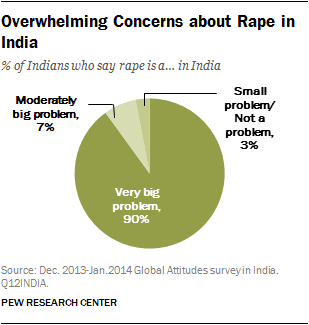Indicate a few pertinent items in this graphic. The ratio of the largest segment to the sum of the two smallest segments is approximately 0.375694444... The percentage value of the smallest segment is 3, and it is correct. 